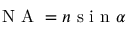<formula> <loc_0><loc_0><loc_500><loc_500>N A = n s i n \alpha</formula> 